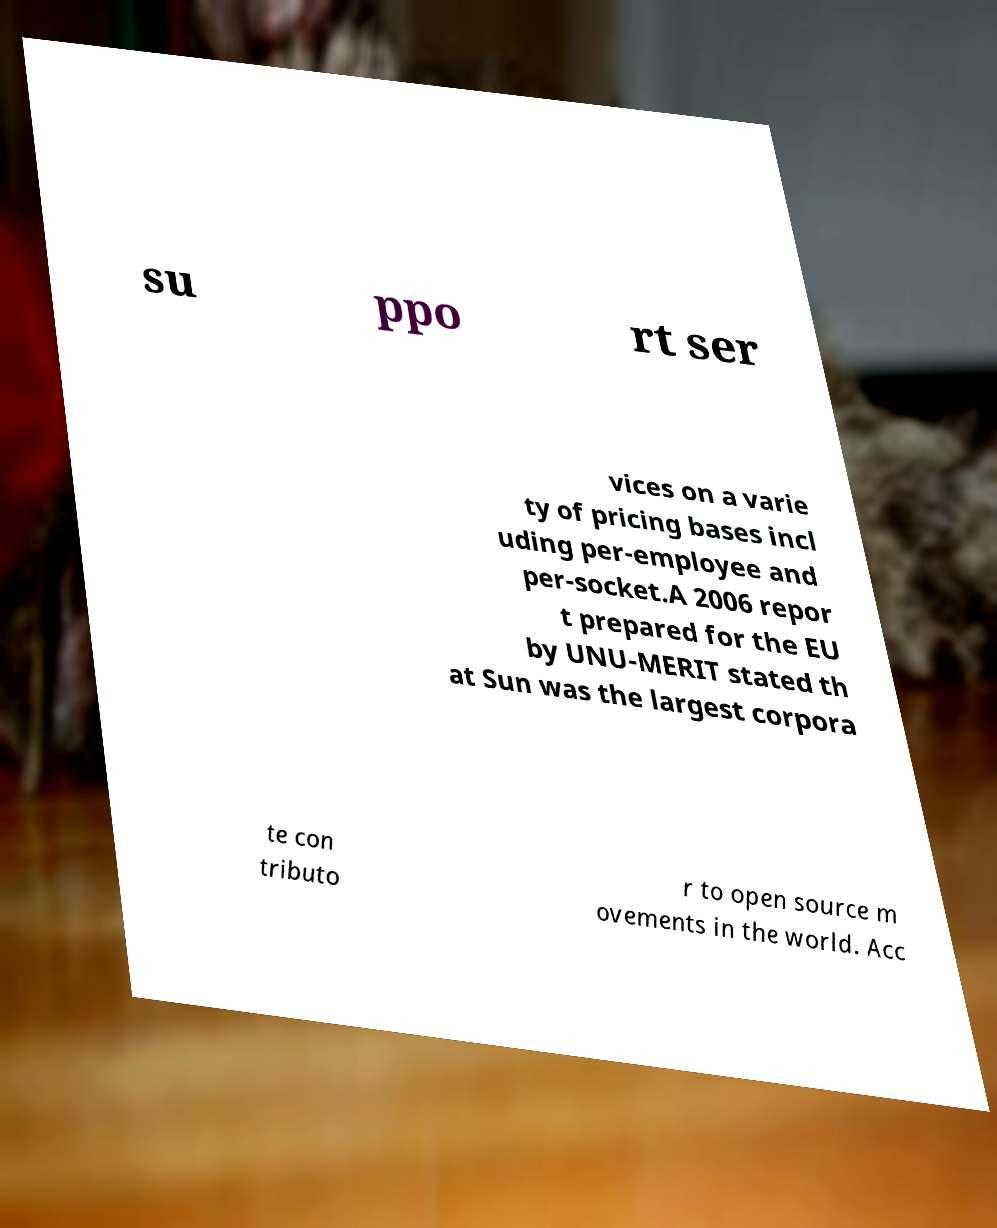For documentation purposes, I need the text within this image transcribed. Could you provide that? su ppo rt ser vices on a varie ty of pricing bases incl uding per-employee and per-socket.A 2006 repor t prepared for the EU by UNU-MERIT stated th at Sun was the largest corpora te con tributo r to open source m ovements in the world. Acc 